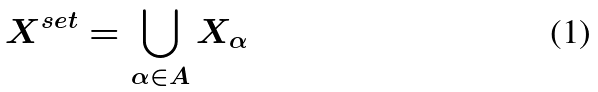<formula> <loc_0><loc_0><loc_500><loc_500>X ^ { s e t } = \bigcup _ { \alpha \in A } X _ { \alpha }</formula> 